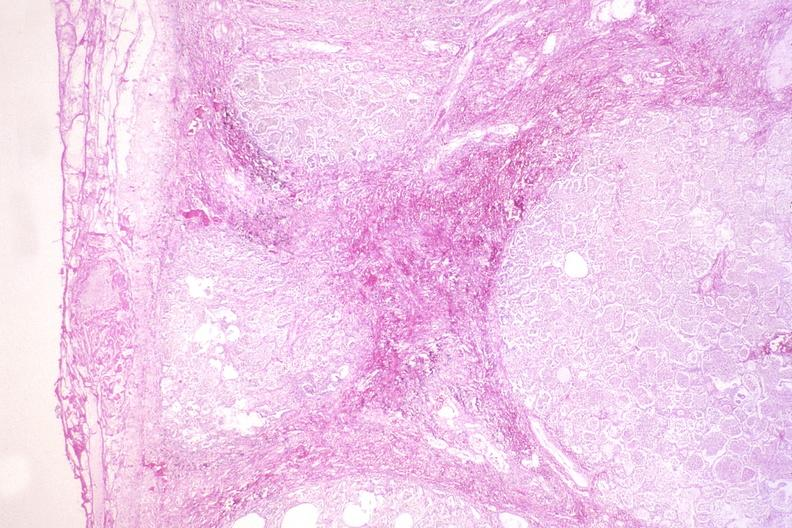what is present?
Answer the question using a single word or phrase. Respiratory 